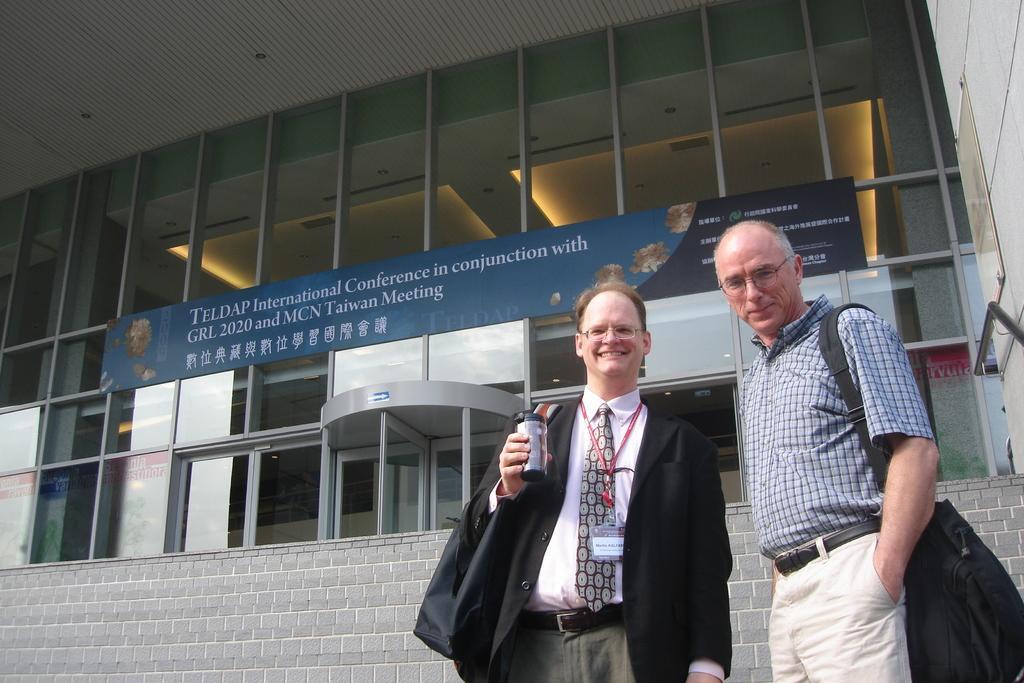Can you describe this image briefly? In this image I see 2 men in which both of them are smiling and I see that this man is carrying a black bag and I see that this man is wearing suit which is of black in color and is holding a thing in his hand and in the background I see the building and I see a board over here on which there are words written and I see the transparent glasses and I see the lights on the ceiling. 